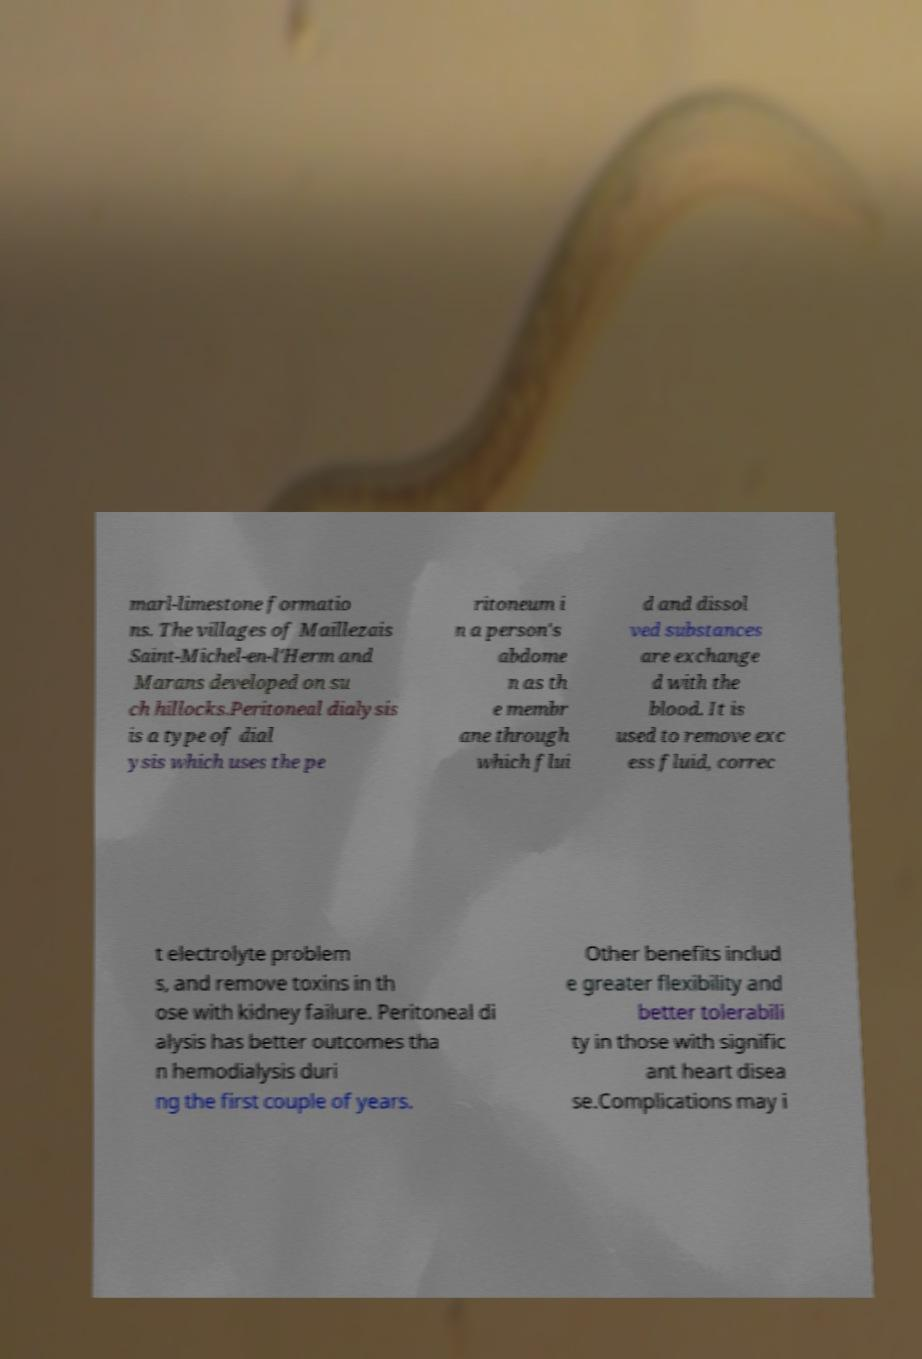Please identify and transcribe the text found in this image. marl-limestone formatio ns. The villages of Maillezais Saint-Michel-en-l'Herm and Marans developed on su ch hillocks.Peritoneal dialysis is a type of dial ysis which uses the pe ritoneum i n a person's abdome n as th e membr ane through which flui d and dissol ved substances are exchange d with the blood. It is used to remove exc ess fluid, correc t electrolyte problem s, and remove toxins in th ose with kidney failure. Peritoneal di alysis has better outcomes tha n hemodialysis duri ng the first couple of years. Other benefits includ e greater flexibility and better tolerabili ty in those with signific ant heart disea se.Complications may i 